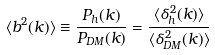<formula> <loc_0><loc_0><loc_500><loc_500>\langle b ^ { 2 } ( k ) \rangle \equiv \frac { P _ { h } ( k ) } { P _ { D M } ( k ) } = \frac { \langle \delta ^ { 2 } _ { h } ( k ) \rangle } { \langle \delta ^ { 2 } _ { D M } ( k ) \rangle }</formula> 